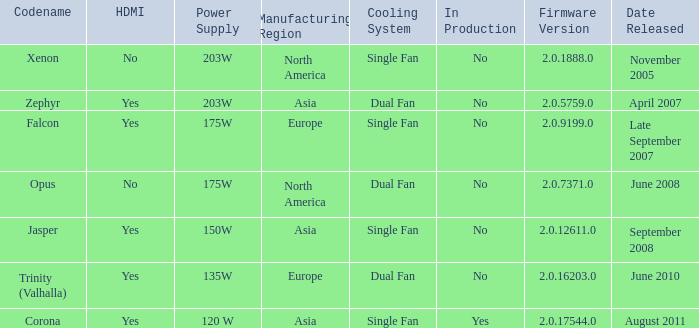Does Trinity (valhalla) have HDMI? Yes. 